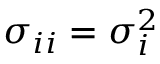Convert formula to latex. <formula><loc_0><loc_0><loc_500><loc_500>\sigma _ { i i } = \sigma _ { i } ^ { 2 }</formula> 